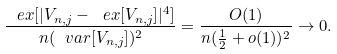<formula> <loc_0><loc_0><loc_500><loc_500>\frac { \ e x [ | V _ { n , j } - \ e x [ V _ { n , j } ] | ^ { 4 } ] } { n ( \ v a r [ V _ { n , j } ] ) ^ { 2 } } = \frac { O ( 1 ) } { n ( \frac { 1 } { 2 } + o ( 1 ) ) ^ { 2 } } \rightarrow 0 .</formula> 